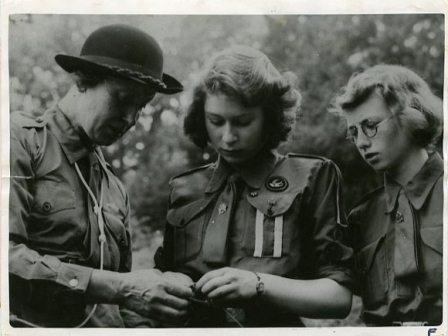Describe the objects in this image and their specific colors. I can see people in ivory, black, gray, and darkgray tones, people in ivory, black, gray, and darkgray tones, people in ivory, black, and gray tones, tie in ivory, gray, and black tones, and tie in ivory, gray, and black tones in this image. 